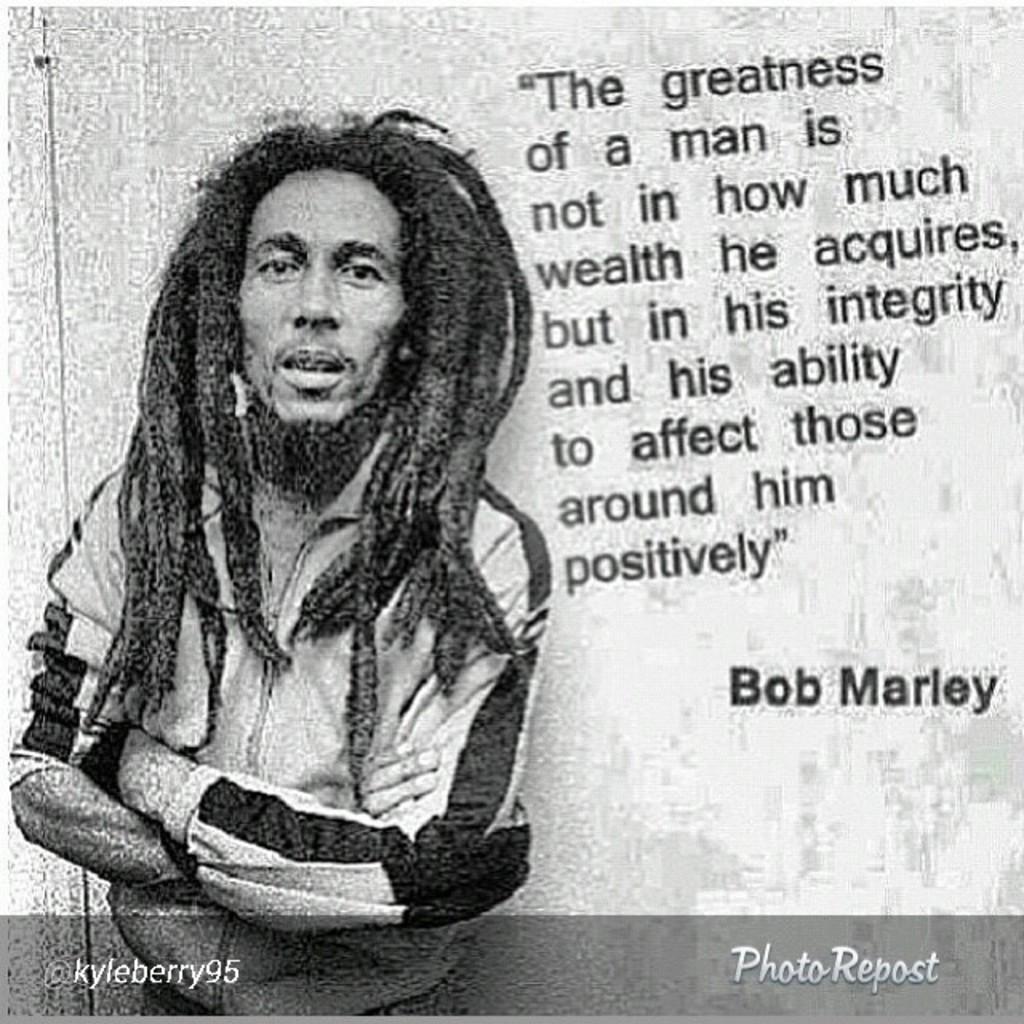How would you summarize this image in a sentence or two? This image consists of a poster and this is a black and white image. On the left side a person is wearing a jacket, standing and looking at the picture. On the right side, I can see some text. 